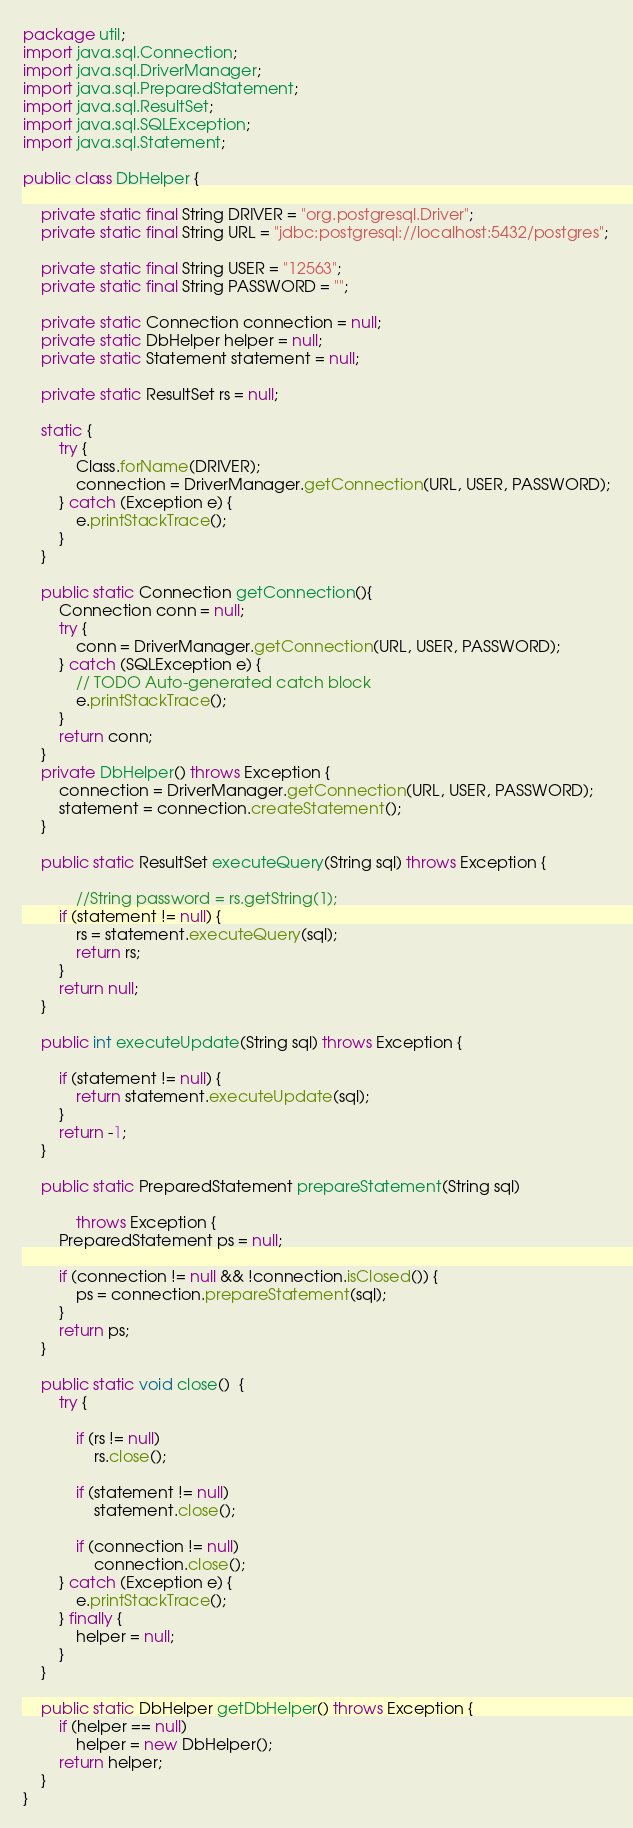<code> <loc_0><loc_0><loc_500><loc_500><_Java_>package util;
import java.sql.Connection;
import java.sql.DriverManager;
import java.sql.PreparedStatement;
import java.sql.ResultSet;
import java.sql.SQLException;
import java.sql.Statement;

public class DbHelper {

	private static final String DRIVER = "org.postgresql.Driver";
	private static final String URL = "jdbc:postgresql://localhost:5432/postgres";

	private static final String USER = "12563";
	private static final String PASSWORD = "";
	
	private static Connection connection = null;
	private static DbHelper helper = null;
	private static Statement statement = null;
	
	private static ResultSet rs = null;
	
	static {
		try {
			Class.forName(DRIVER);
			connection = DriverManager.getConnection(URL, USER, PASSWORD);
		} catch (Exception e) {
			e.printStackTrace();
		}
	}

	public static Connection getConnection(){
		Connection conn = null;
		try {
			conn = DriverManager.getConnection(URL, USER, PASSWORD);
		} catch (SQLException e) {
			// TODO Auto-generated catch block
			e.printStackTrace();
		}
		return conn;
	}
	private DbHelper() throws Exception {
		connection = DriverManager.getConnection(URL, USER, PASSWORD);
		statement = connection.createStatement();
	}
	
	public static ResultSet executeQuery(String sql) throws Exception {
		
			//String password = rs.getString(1);
		if (statement != null) {
			rs = statement.executeQuery(sql);
			return rs;
		}
		return null;
	}
	
	public int executeUpdate(String sql) throws Exception {
		
		if (statement != null) {
			return statement.executeUpdate(sql);
		}
		return -1;
	}
	
	public static PreparedStatement prepareStatement(String sql) 
	
			throws Exception {
		PreparedStatement ps = null;
		
		if (connection != null && !connection.isClosed()) {
			ps = connection.prepareStatement(sql);
		}
		return ps;
	}
	
	public static void close()  {
		try {
			
			if (rs != null)
				rs.close();
		
			if (statement != null)
				statement.close();
	
			if (connection != null) 
				connection.close();
		} catch (Exception e) {
			e.printStackTrace();
		} finally {
			helper = null;
		}
	}

	public static DbHelper getDbHelper() throws Exception {
		if (helper == null)
			helper = new DbHelper();
		return helper;
	}
}
</code> 